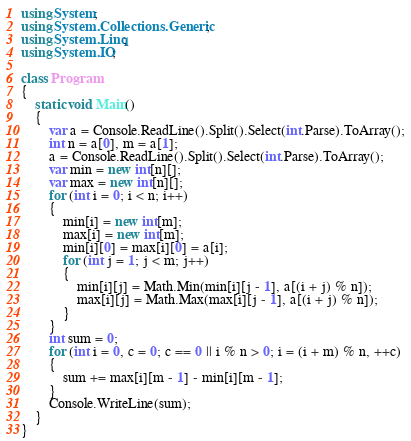Convert code to text. <code><loc_0><loc_0><loc_500><loc_500><_C#_>using System;
using System.Collections.Generic;
using System.Linq;
using System.IO;

class Program
{
    static void Main()
    {
        var a = Console.ReadLine().Split().Select(int.Parse).ToArray();
        int n = a[0], m = a[1];
        a = Console.ReadLine().Split().Select(int.Parse).ToArray();
        var min = new int[n][];
        var max = new int[n][];
        for (int i = 0; i < n; i++)
        {
            min[i] = new int[m];
            max[i] = new int[m];
            min[i][0] = max[i][0] = a[i];
            for (int j = 1; j < m; j++)
            {
                min[i][j] = Math.Min(min[i][j - 1], a[(i + j) % n]);
                max[i][j] = Math.Max(max[i][j - 1], a[(i + j) % n]);
            }
        }
        int sum = 0;
        for (int i = 0, c = 0; c == 0 || i % n > 0; i = (i + m) % n, ++c)
        {
            sum += max[i][m - 1] - min[i][m - 1];
        }
        Console.WriteLine(sum);
    }
}</code> 